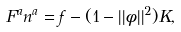<formula> <loc_0><loc_0><loc_500><loc_500>F ^ { a } n ^ { a } = f - ( 1 - | | \phi | | ^ { 2 } ) K ,</formula> 